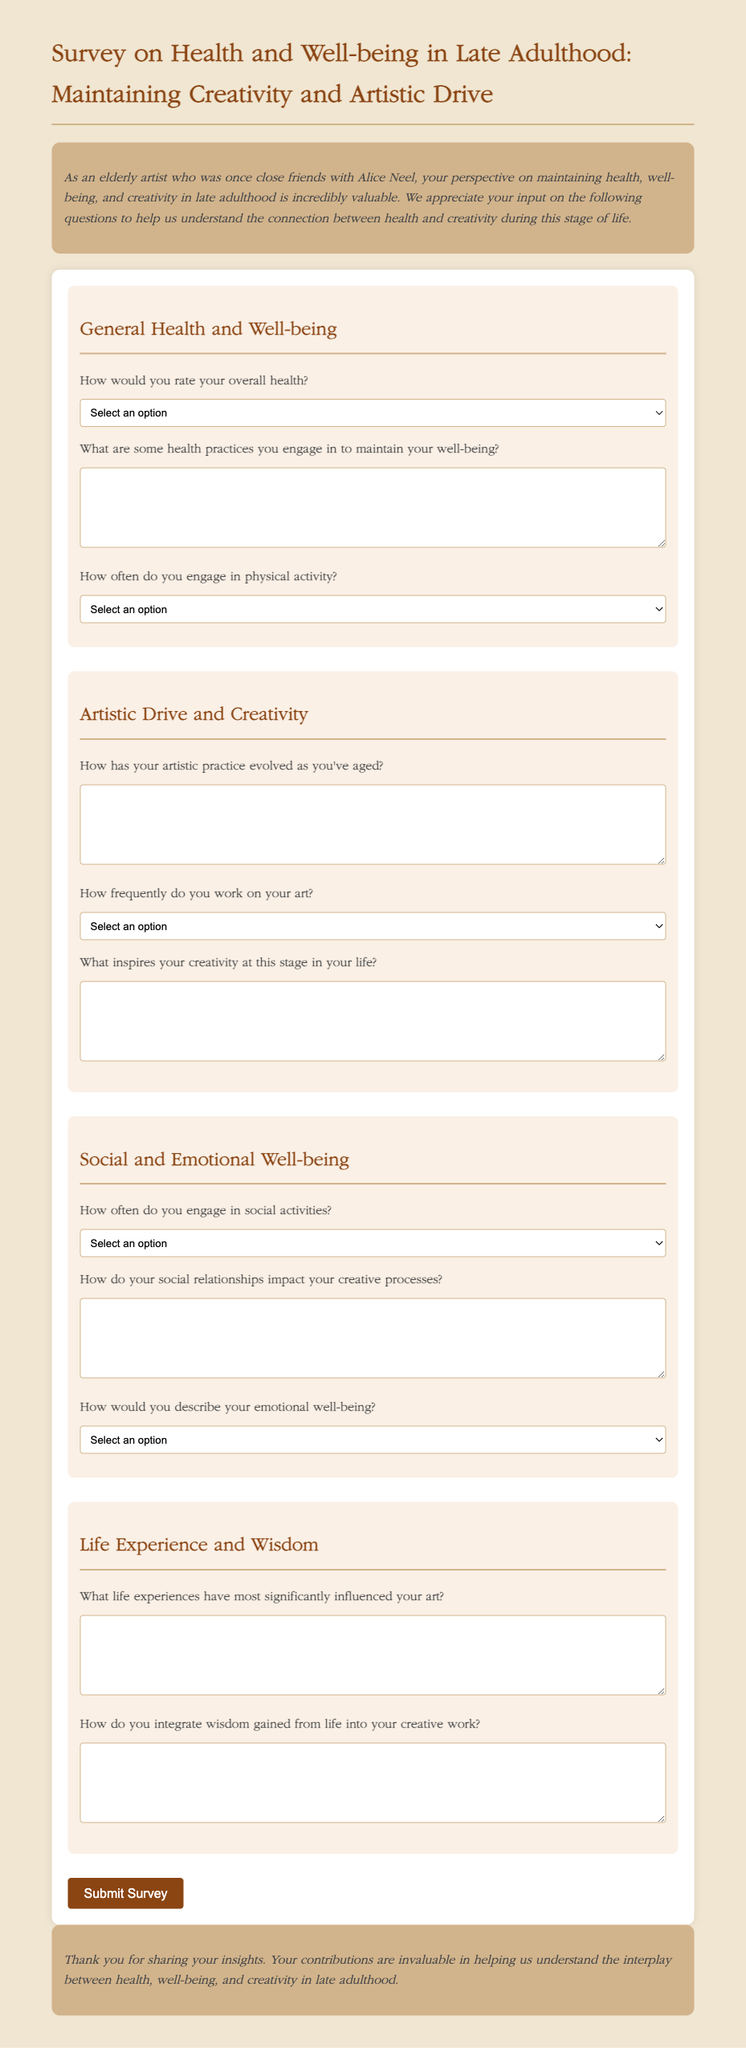How would you rate your overall health? The document provides a dropdown selection for the general health rating options.
Answer: Excellent What is the main purpose of this survey? The introduction part of the document explains the aim of gathering insights on health and creativity in late adulthood.
Answer: To understand the connection between health and creativity How frequently do you work on your art? The survey section includes a question with options regarding the frequency of artistic work engagement.
Answer: Daily What aspects of well-being does the survey inquire about? The survey encompasses questions regarding general health, artistic drive, social-emotional well-being, and life experiences.
Answer: Health, Artistic drive, Social-emotional well-being, Life experiences What is one question related to social activities? A section in the survey specifically focuses on social activities with a corresponding question.
Answer: How often do you engage in social activities? 